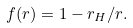<formula> <loc_0><loc_0><loc_500><loc_500>f ( r ) = 1 - r _ { H } / r .</formula> 